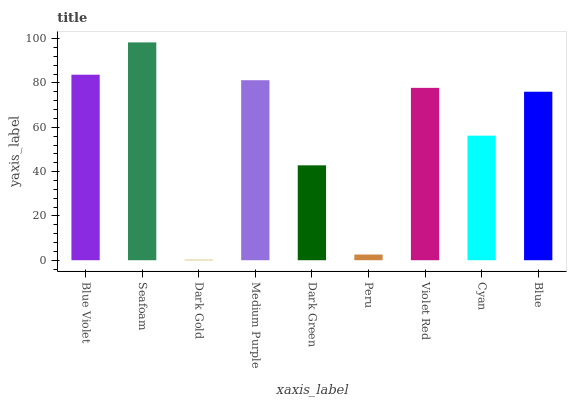Is Dark Gold the minimum?
Answer yes or no. Yes. Is Seafoam the maximum?
Answer yes or no. Yes. Is Seafoam the minimum?
Answer yes or no. No. Is Dark Gold the maximum?
Answer yes or no. No. Is Seafoam greater than Dark Gold?
Answer yes or no. Yes. Is Dark Gold less than Seafoam?
Answer yes or no. Yes. Is Dark Gold greater than Seafoam?
Answer yes or no. No. Is Seafoam less than Dark Gold?
Answer yes or no. No. Is Blue the high median?
Answer yes or no. Yes. Is Blue the low median?
Answer yes or no. Yes. Is Peru the high median?
Answer yes or no. No. Is Seafoam the low median?
Answer yes or no. No. 